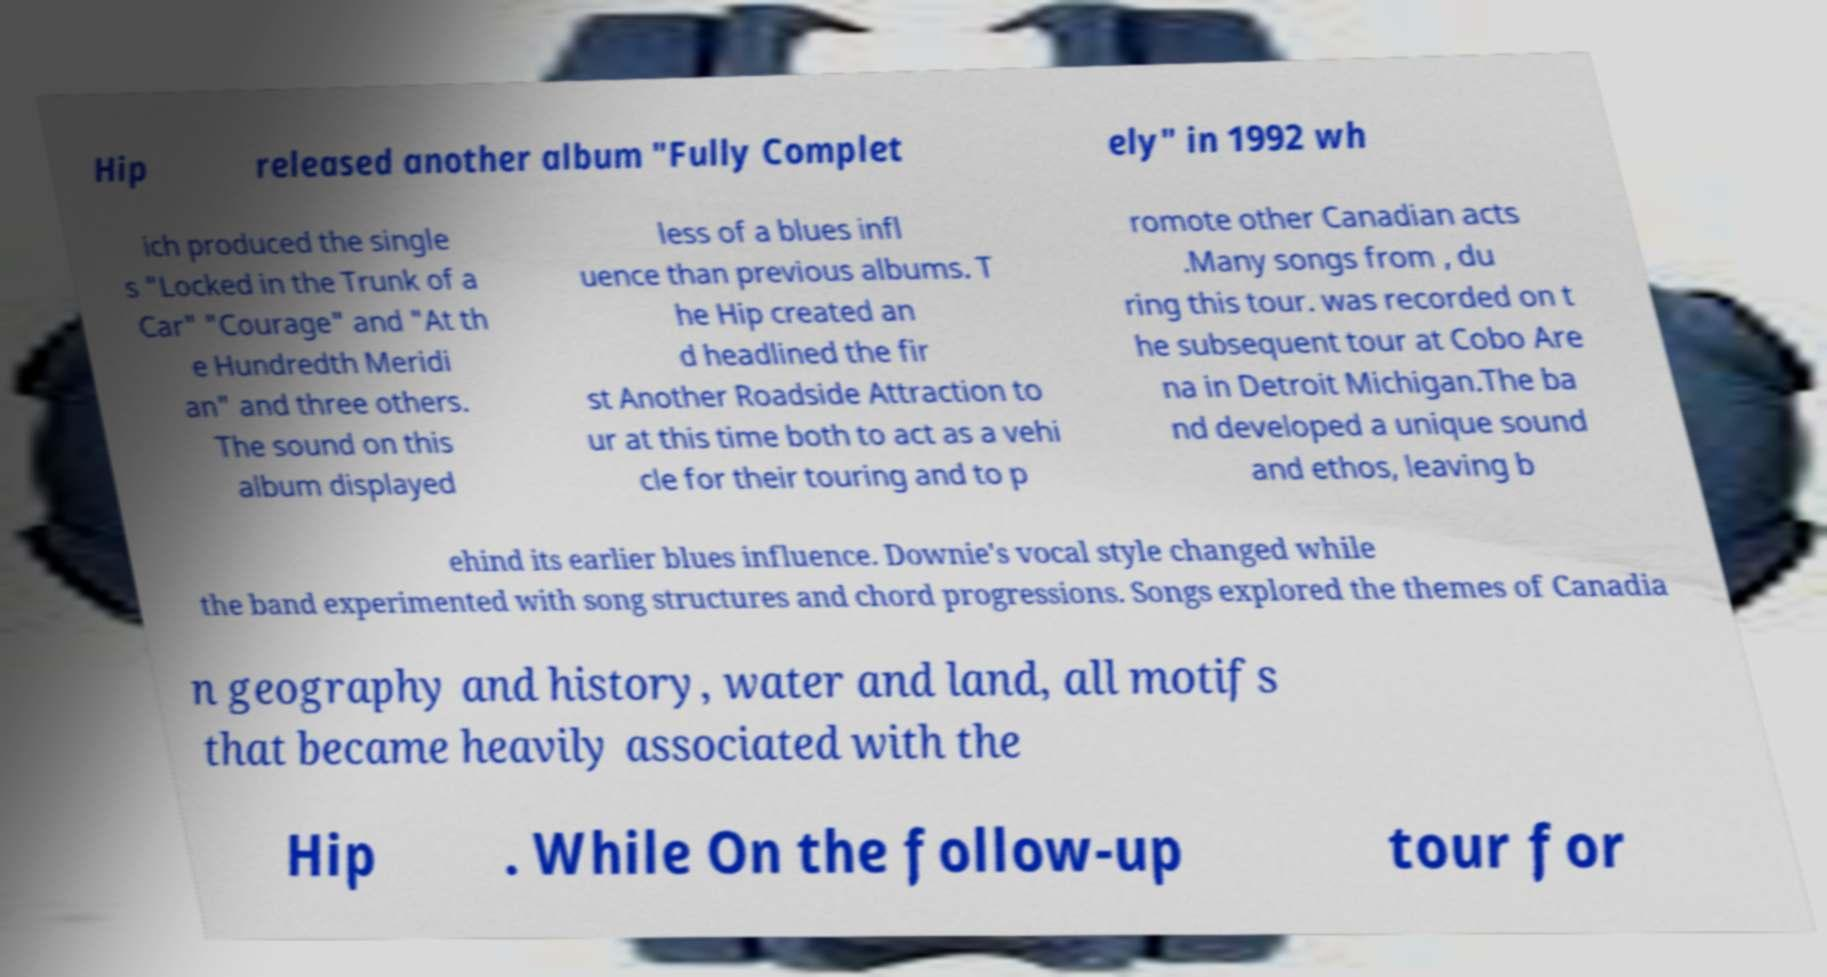Please identify and transcribe the text found in this image. Hip released another album "Fully Complet ely" in 1992 wh ich produced the single s "Locked in the Trunk of a Car" "Courage" and "At th e Hundredth Meridi an" and three others. The sound on this album displayed less of a blues infl uence than previous albums. T he Hip created an d headlined the fir st Another Roadside Attraction to ur at this time both to act as a vehi cle for their touring and to p romote other Canadian acts .Many songs from , du ring this tour. was recorded on t he subsequent tour at Cobo Are na in Detroit Michigan.The ba nd developed a unique sound and ethos, leaving b ehind its earlier blues influence. Downie's vocal style changed while the band experimented with song structures and chord progressions. Songs explored the themes of Canadia n geography and history, water and land, all motifs that became heavily associated with the Hip . While On the follow-up tour for 